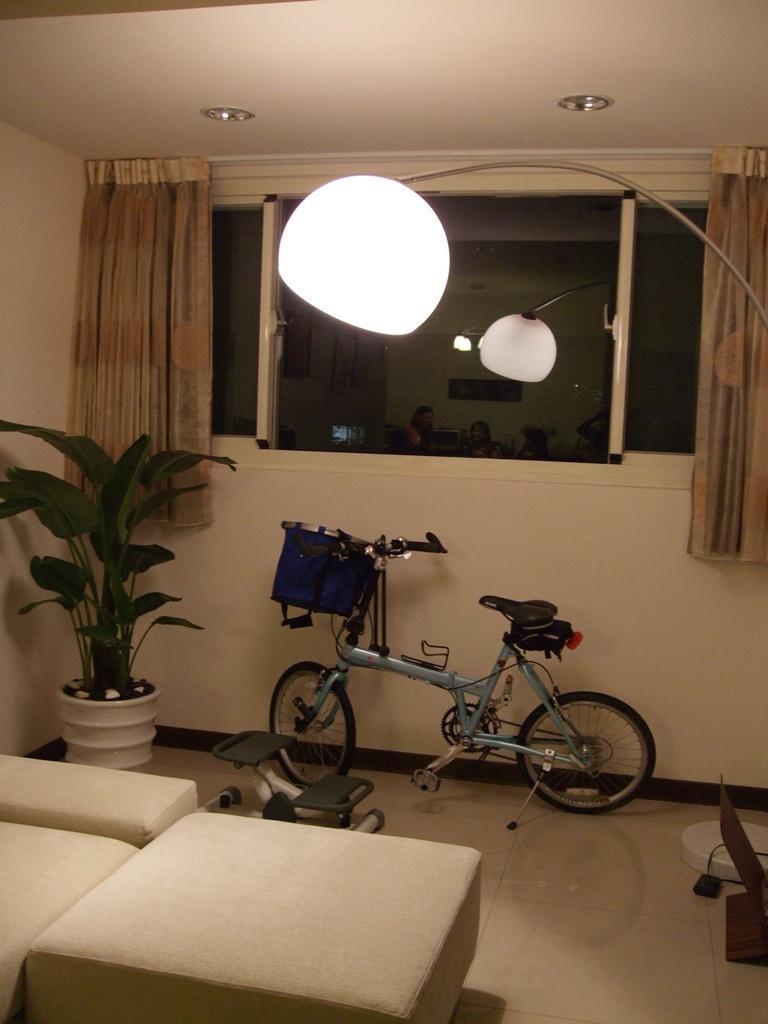Describe this image in one or two sentences. Picture inside of a room. In this room there is a plant, bicycle and couch. This is a window with curtain. This is a lamp. 